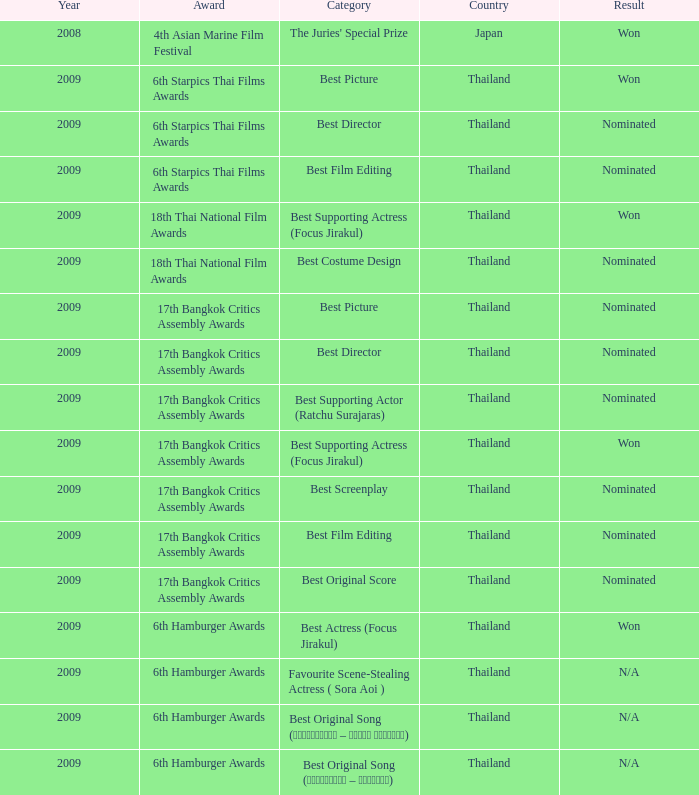Which Country has a Result of nominated, an Award of 17th bangkok critics assembly awards, and a Category of best screenplay? Thailand. 